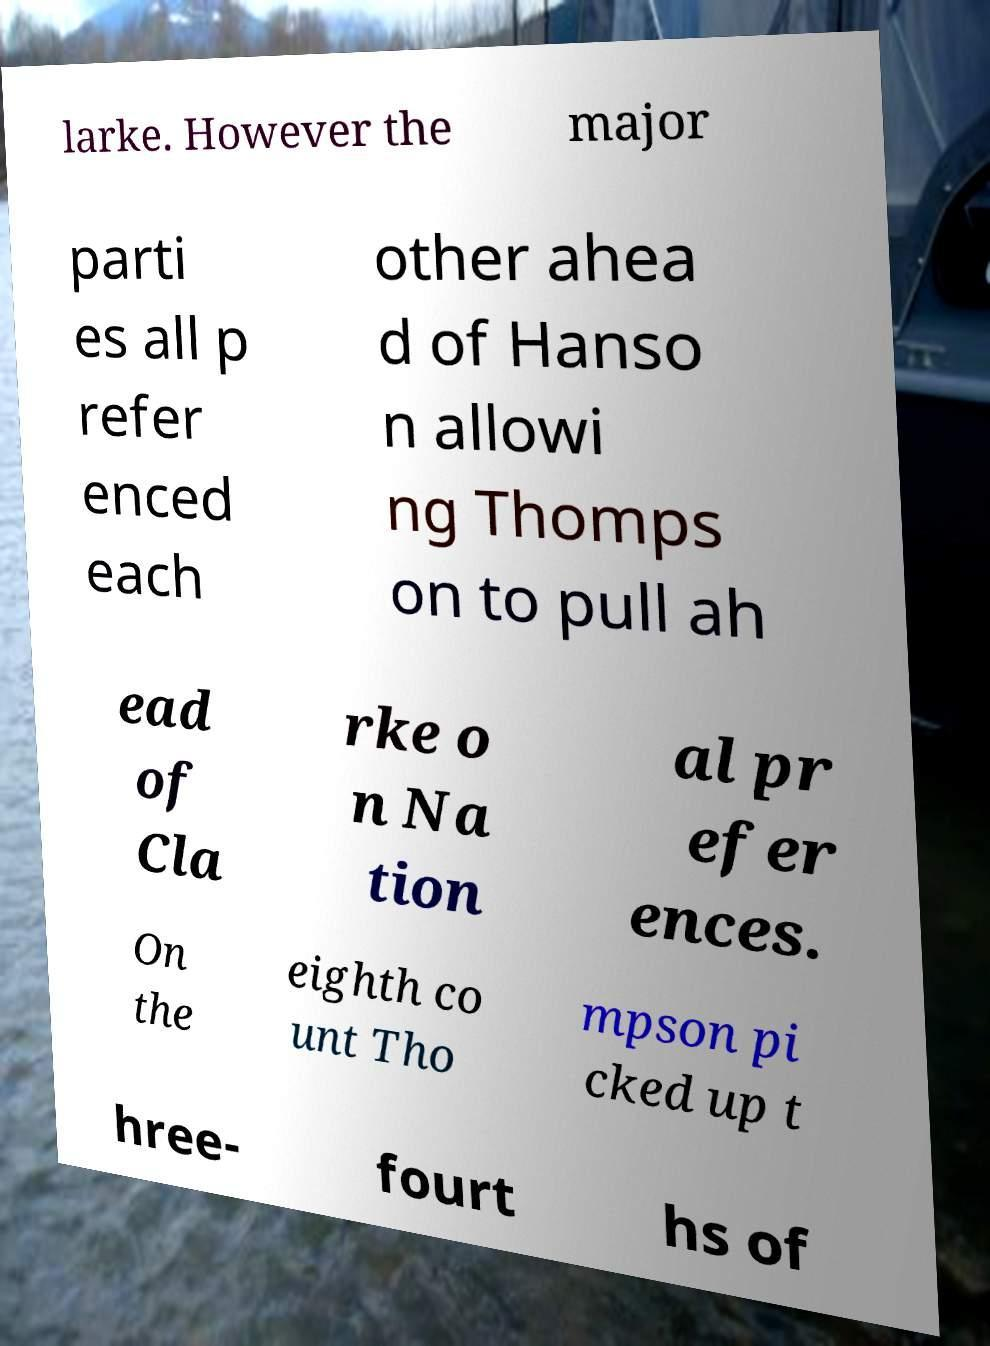What messages or text are displayed in this image? I need them in a readable, typed format. larke. However the major parti es all p refer enced each other ahea d of Hanso n allowi ng Thomps on to pull ah ead of Cla rke o n Na tion al pr efer ences. On the eighth co unt Tho mpson pi cked up t hree- fourt hs of 